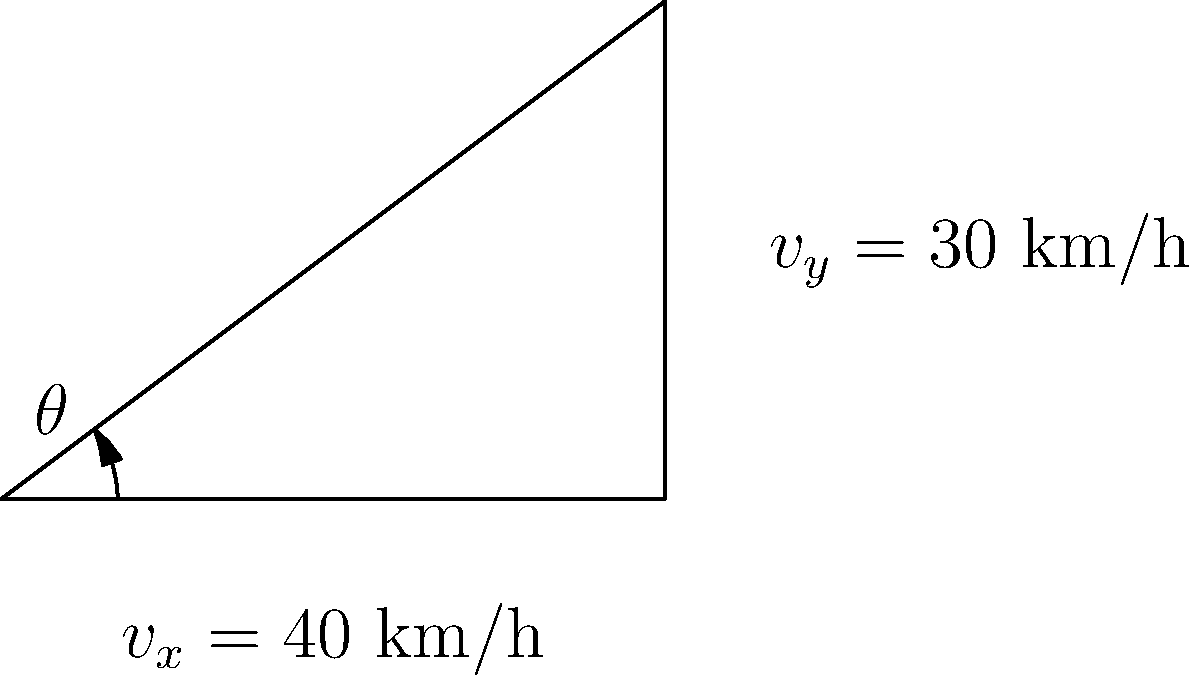Your friend Harry Hawkins is trying to distract himself from his grief by working on a navigation problem. He's analyzing a ship's heading and asks for your help. The ship's velocity components are $v_x = 40$ km/h (eastward) and $v_y = 30$ km/h (northward). What is the angle $\theta$ of the ship's heading measured counterclockwise from due east? Let's approach this step-by-step to help Harry:

1) The ship's motion can be represented as a right-angled triangle, where:
   - The adjacent side (east component) is $v_x = 40$ km/h
   - The opposite side (north component) is $v_y = 30$ km/h
   - The angle $\theta$ is what we're looking for

2) In this case, we can use the arctangent function to find the angle:

   $\theta = \tan^{-1}(\frac{\text{opposite}}{\text{adjacent}}) = \tan^{-1}(\frac{v_y}{v_x})$

3) Substituting the values:

   $\theta = \tan^{-1}(\frac{30}{40})$

4) Simplifying:

   $\theta = \tan^{-1}(0.75)$

5) Using a calculator or trigonometric tables:

   $\theta \approx 36.87°$

Therefore, the ship's heading is approximately 36.87° north of east.
Answer: $36.87°$ 